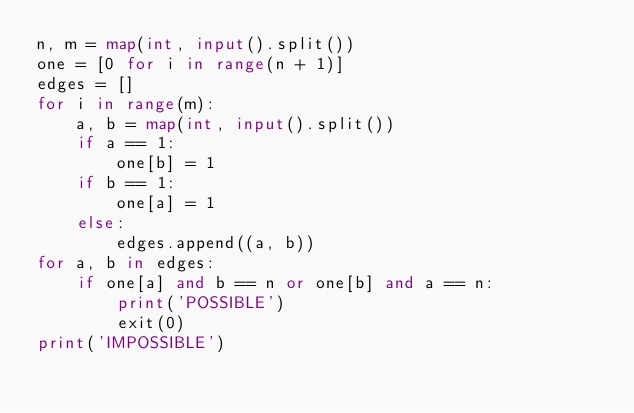Convert code to text. <code><loc_0><loc_0><loc_500><loc_500><_Python_>n, m = map(int, input().split())
one = [0 for i in range(n + 1)]
edges = []
for i in range(m):
    a, b = map(int, input().split())
    if a == 1:
        one[b] = 1
    if b == 1:
        one[a] = 1
    else:
        edges.append((a, b))
for a, b in edges:
    if one[a] and b == n or one[b] and a == n:
        print('POSSIBLE')
        exit(0)
print('IMPOSSIBLE')
</code> 